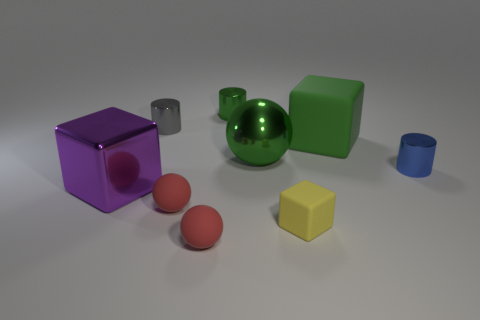What is the size of the cylinder that is the same color as the big rubber block?
Your answer should be compact. Small. How many green metal things have the same size as the yellow cube?
Give a very brief answer. 1. Are there the same number of green spheres behind the gray metal thing and large matte cylinders?
Your answer should be very brief. Yes. How many shiny objects are left of the green metal cylinder and in front of the gray thing?
Provide a succinct answer. 1. The other cube that is made of the same material as the green cube is what size?
Provide a short and direct response. Small. What number of gray things are the same shape as the small blue metallic object?
Ensure brevity in your answer.  1. Is the number of tiny gray things right of the blue cylinder greater than the number of purple blocks?
Give a very brief answer. No. What shape is the rubber object that is on the right side of the large sphere and in front of the large green cube?
Provide a succinct answer. Cube. Is the green sphere the same size as the purple thing?
Offer a very short reply. Yes. There is a purple object; what number of small green metallic things are left of it?
Offer a terse response. 0. 